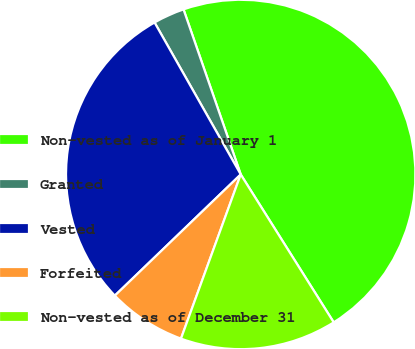Convert chart to OTSL. <chart><loc_0><loc_0><loc_500><loc_500><pie_chart><fcel>Non-vested as of January 1<fcel>Granted<fcel>Vested<fcel>Forfeited<fcel>Non-vested as of December 31<nl><fcel>46.38%<fcel>2.9%<fcel>28.99%<fcel>7.25%<fcel>14.49%<nl></chart> 